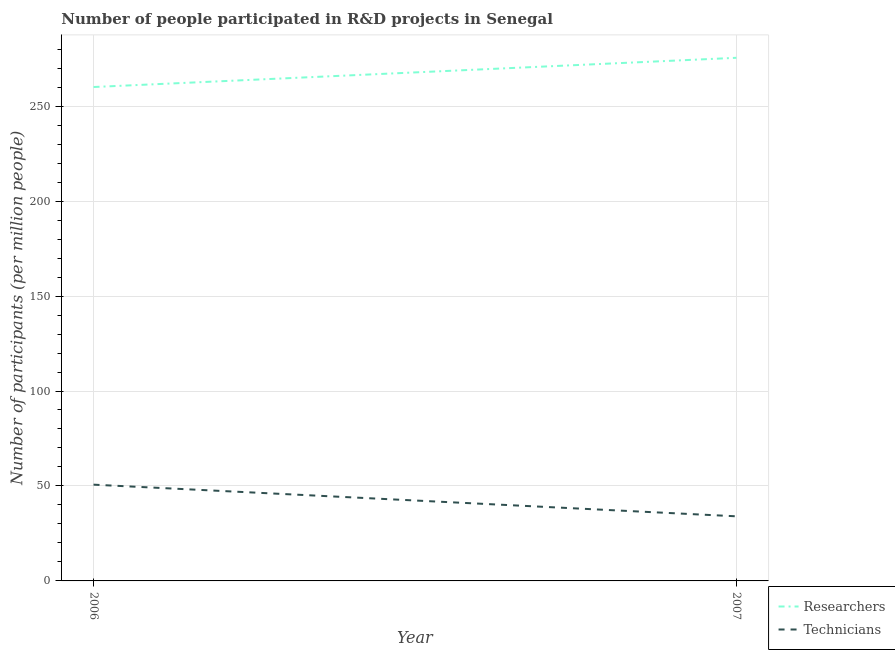Is the number of lines equal to the number of legend labels?
Your response must be concise. Yes. What is the number of technicians in 2007?
Give a very brief answer. 34.01. Across all years, what is the maximum number of technicians?
Make the answer very short. 50.68. Across all years, what is the minimum number of technicians?
Keep it short and to the point. 34.01. In which year was the number of technicians maximum?
Give a very brief answer. 2006. In which year was the number of technicians minimum?
Provide a succinct answer. 2007. What is the total number of technicians in the graph?
Your answer should be compact. 84.69. What is the difference between the number of technicians in 2006 and that in 2007?
Keep it short and to the point. 16.67. What is the difference between the number of researchers in 2007 and the number of technicians in 2006?
Offer a terse response. 224.76. What is the average number of researchers per year?
Your answer should be compact. 267.75. In the year 2007, what is the difference between the number of researchers and number of technicians?
Ensure brevity in your answer.  241.43. What is the ratio of the number of technicians in 2006 to that in 2007?
Ensure brevity in your answer.  1.49. Does the number of technicians monotonically increase over the years?
Provide a short and direct response. No. How many lines are there?
Provide a short and direct response. 2. How many years are there in the graph?
Your answer should be compact. 2. What is the difference between two consecutive major ticks on the Y-axis?
Make the answer very short. 50. Are the values on the major ticks of Y-axis written in scientific E-notation?
Provide a short and direct response. No. Does the graph contain any zero values?
Give a very brief answer. No. How many legend labels are there?
Your response must be concise. 2. How are the legend labels stacked?
Ensure brevity in your answer.  Vertical. What is the title of the graph?
Offer a very short reply. Number of people participated in R&D projects in Senegal. Does "International Tourists" appear as one of the legend labels in the graph?
Provide a succinct answer. No. What is the label or title of the Y-axis?
Your answer should be very brief. Number of participants (per million people). What is the Number of participants (per million people) in Researchers in 2006?
Offer a very short reply. 260.05. What is the Number of participants (per million people) in Technicians in 2006?
Offer a very short reply. 50.68. What is the Number of participants (per million people) of Researchers in 2007?
Your answer should be compact. 275.44. What is the Number of participants (per million people) of Technicians in 2007?
Offer a terse response. 34.01. Across all years, what is the maximum Number of participants (per million people) in Researchers?
Your answer should be compact. 275.44. Across all years, what is the maximum Number of participants (per million people) of Technicians?
Keep it short and to the point. 50.68. Across all years, what is the minimum Number of participants (per million people) of Researchers?
Give a very brief answer. 260.05. Across all years, what is the minimum Number of participants (per million people) of Technicians?
Your answer should be compact. 34.01. What is the total Number of participants (per million people) in Researchers in the graph?
Offer a terse response. 535.49. What is the total Number of participants (per million people) of Technicians in the graph?
Make the answer very short. 84.69. What is the difference between the Number of participants (per million people) of Researchers in 2006 and that in 2007?
Ensure brevity in your answer.  -15.39. What is the difference between the Number of participants (per million people) in Technicians in 2006 and that in 2007?
Your response must be concise. 16.67. What is the difference between the Number of participants (per million people) of Researchers in 2006 and the Number of participants (per million people) of Technicians in 2007?
Make the answer very short. 226.04. What is the average Number of participants (per million people) in Researchers per year?
Give a very brief answer. 267.75. What is the average Number of participants (per million people) of Technicians per year?
Keep it short and to the point. 42.35. In the year 2006, what is the difference between the Number of participants (per million people) of Researchers and Number of participants (per million people) of Technicians?
Your response must be concise. 209.37. In the year 2007, what is the difference between the Number of participants (per million people) in Researchers and Number of participants (per million people) in Technicians?
Your answer should be compact. 241.43. What is the ratio of the Number of participants (per million people) in Researchers in 2006 to that in 2007?
Make the answer very short. 0.94. What is the ratio of the Number of participants (per million people) of Technicians in 2006 to that in 2007?
Give a very brief answer. 1.49. What is the difference between the highest and the second highest Number of participants (per million people) in Researchers?
Keep it short and to the point. 15.39. What is the difference between the highest and the second highest Number of participants (per million people) in Technicians?
Provide a succinct answer. 16.67. What is the difference between the highest and the lowest Number of participants (per million people) of Researchers?
Provide a succinct answer. 15.39. What is the difference between the highest and the lowest Number of participants (per million people) in Technicians?
Offer a very short reply. 16.67. 